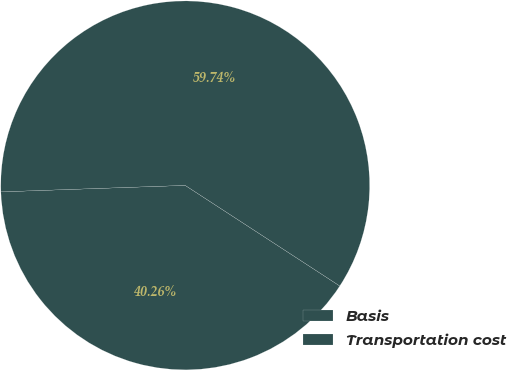Convert chart to OTSL. <chart><loc_0><loc_0><loc_500><loc_500><pie_chart><fcel>Basis<fcel>Transportation cost<nl><fcel>40.26%<fcel>59.74%<nl></chart> 